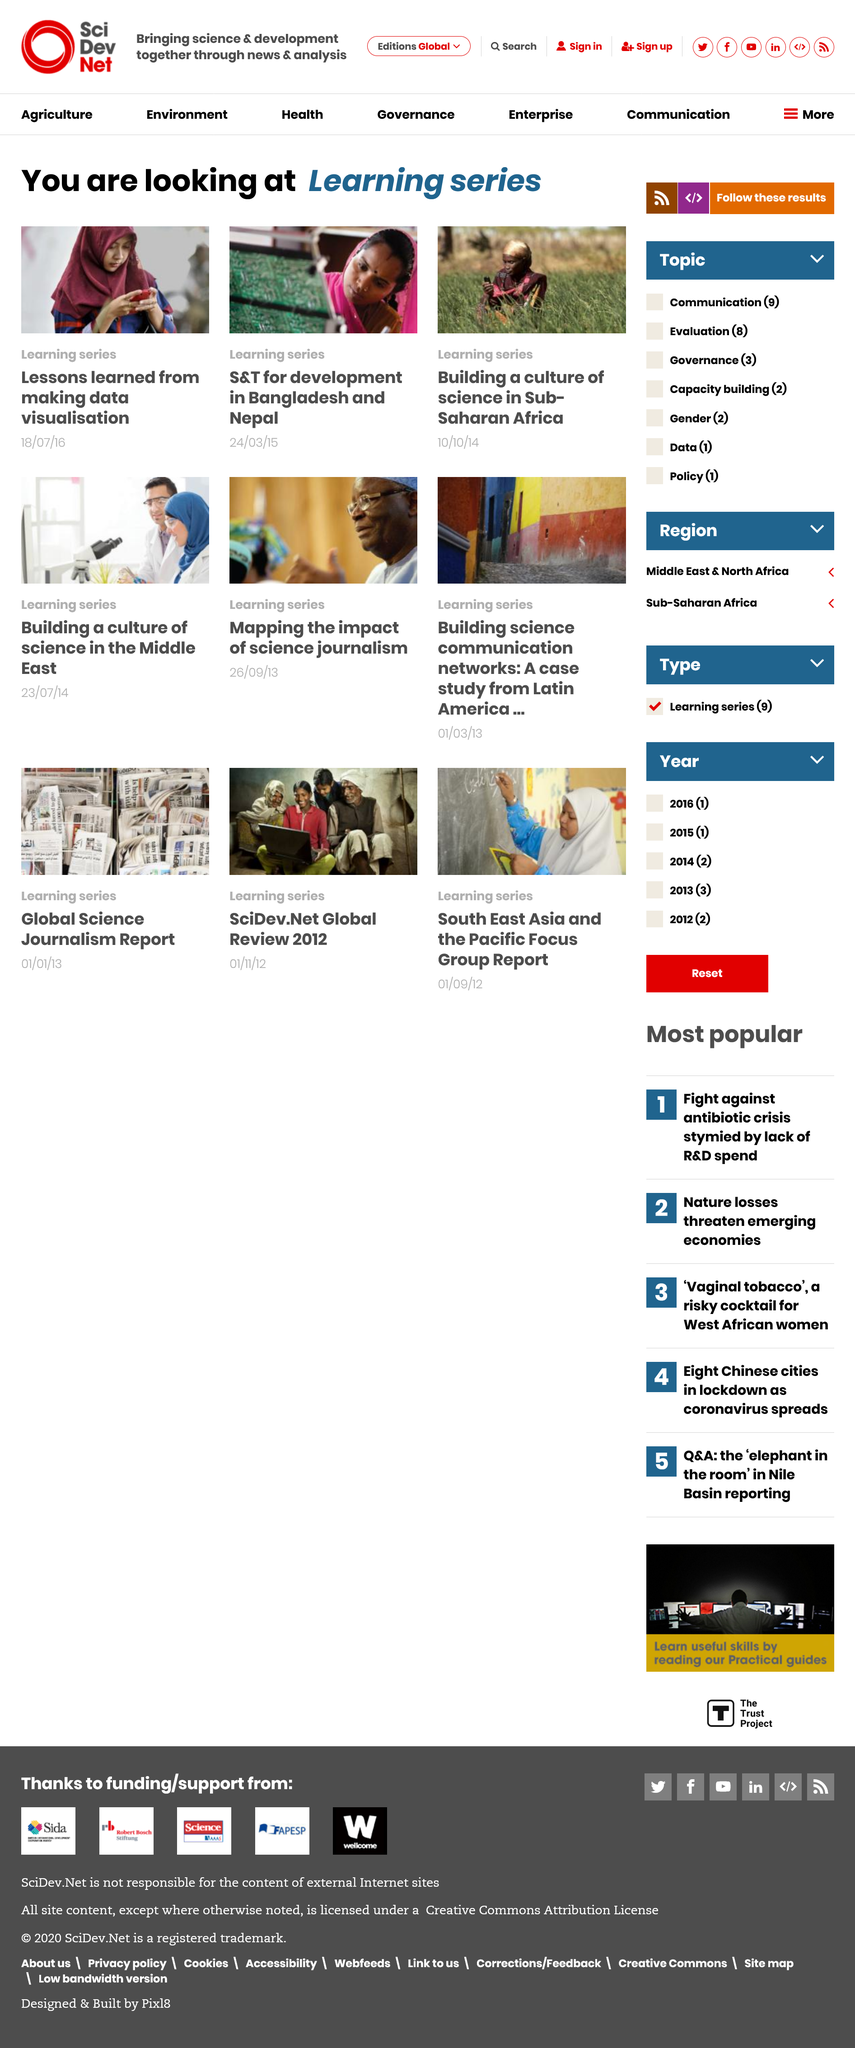Mention a couple of crucial points in this snapshot. The goal is to establish a culture of science in Sub-Saharan Africa, with a focus on building a foundation for future scientific advancements. Three photographs are shown in the image. The section on S&T for development mentions Bangladesh and Nepal as the two countries. 